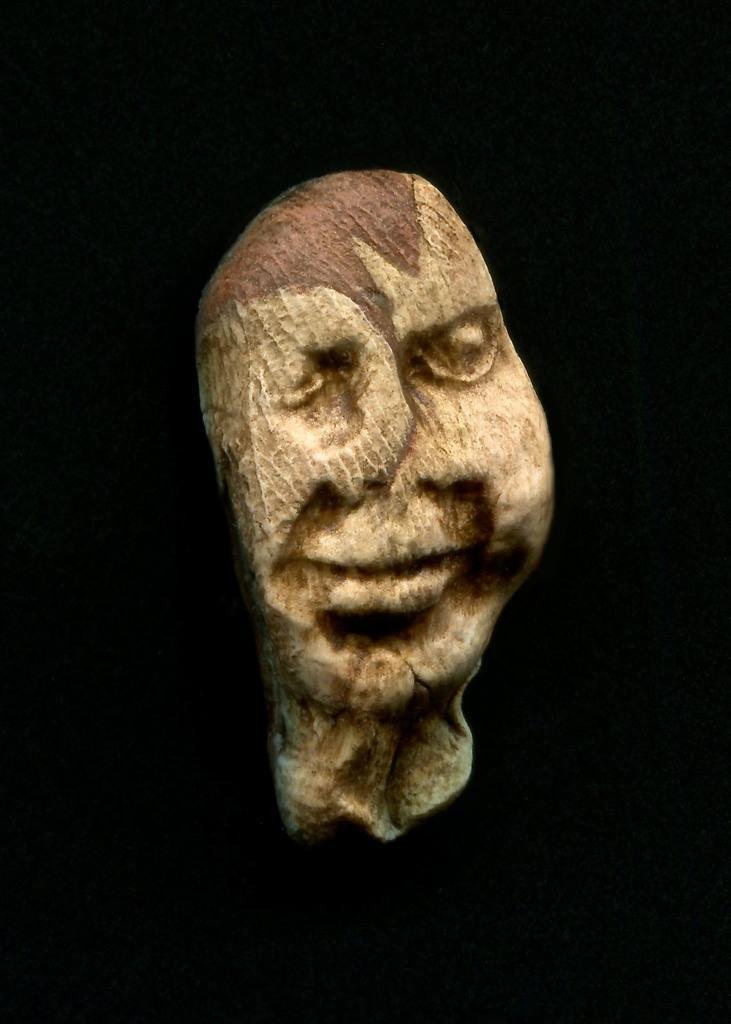How would you summarize this image in a sentence or two? In this image I can see an object which is cream and brown in color which is in the shape of a human head and I can see the black colored background. 